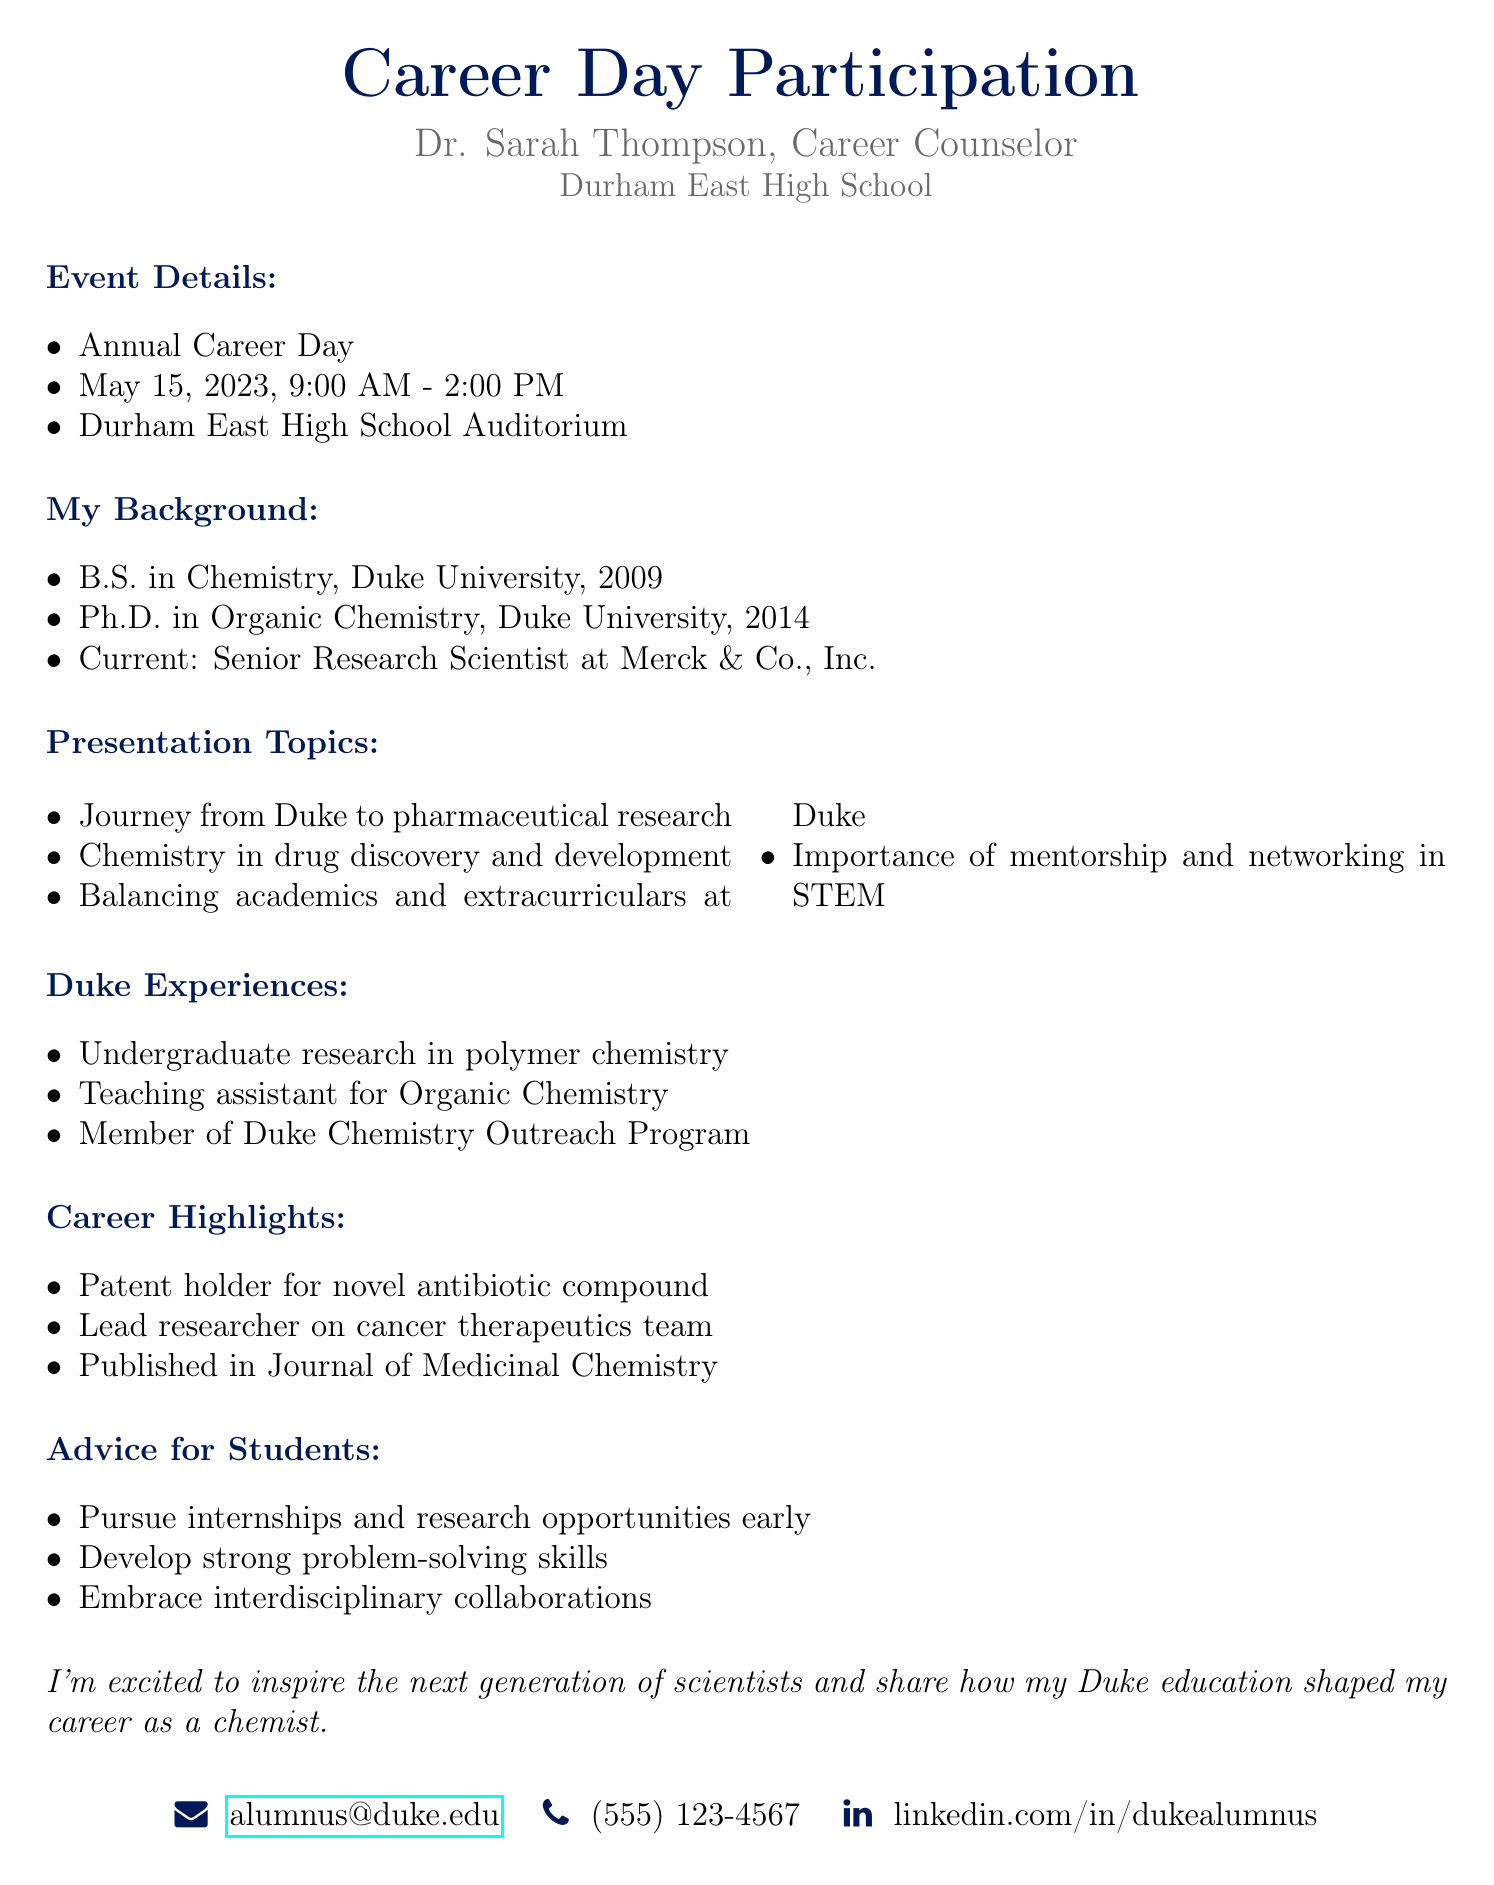What is the name of the recipient of the mail? The recipient of the mail is Dr. Sarah Thompson, who is the Career Counselor at Durham East High School.
Answer: Dr. Sarah Thompson What is the date of the Annual Career Day? The Annual Career Day is scheduled for May 15, 2023.
Answer: May 15, 2023 What is the current position of the sender? The sender is currently a Senior Research Scientist at Merck & Co., Inc.
Answer: Senior Research Scientist at Merck & Co., Inc How many topics will be covered in the presentation? The document lists four presentation topics for the event.
Answer: Four What is one piece of advice for students mentioned in the document? The document suggests that students should pursue internships and research opportunities early as one piece of advice.
Answer: Pursue internships and research opportunities early What educational level did the sender attain at Duke University? The sender completed both undergraduate and graduate degrees at Duke University, obtaining a B.S. and a Ph.D.
Answer: B.S. and Ph.D How many career highlights are mentioned in the document? The document mentions three career highlights of the sender.
Answer: Three What role did the sender have in the Duke Chemistry Outreach Program? The sender was a member of the Duke Chemistry Outreach Program during their time at Duke.
Answer: Member In what field did the sender obtain their Ph.D.? The sender obtained their Ph.D. in Organic Chemistry.
Answer: Organic Chemistry 